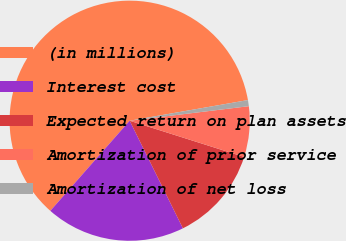<chart> <loc_0><loc_0><loc_500><loc_500><pie_chart><fcel>(in millions)<fcel>Interest cost<fcel>Expected return on plan assets<fcel>Amortization of prior service<fcel>Amortization of net loss<nl><fcel>60.77%<fcel>18.8%<fcel>12.81%<fcel>6.81%<fcel>0.82%<nl></chart> 